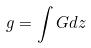Convert formula to latex. <formula><loc_0><loc_0><loc_500><loc_500>g = \int G d z</formula> 